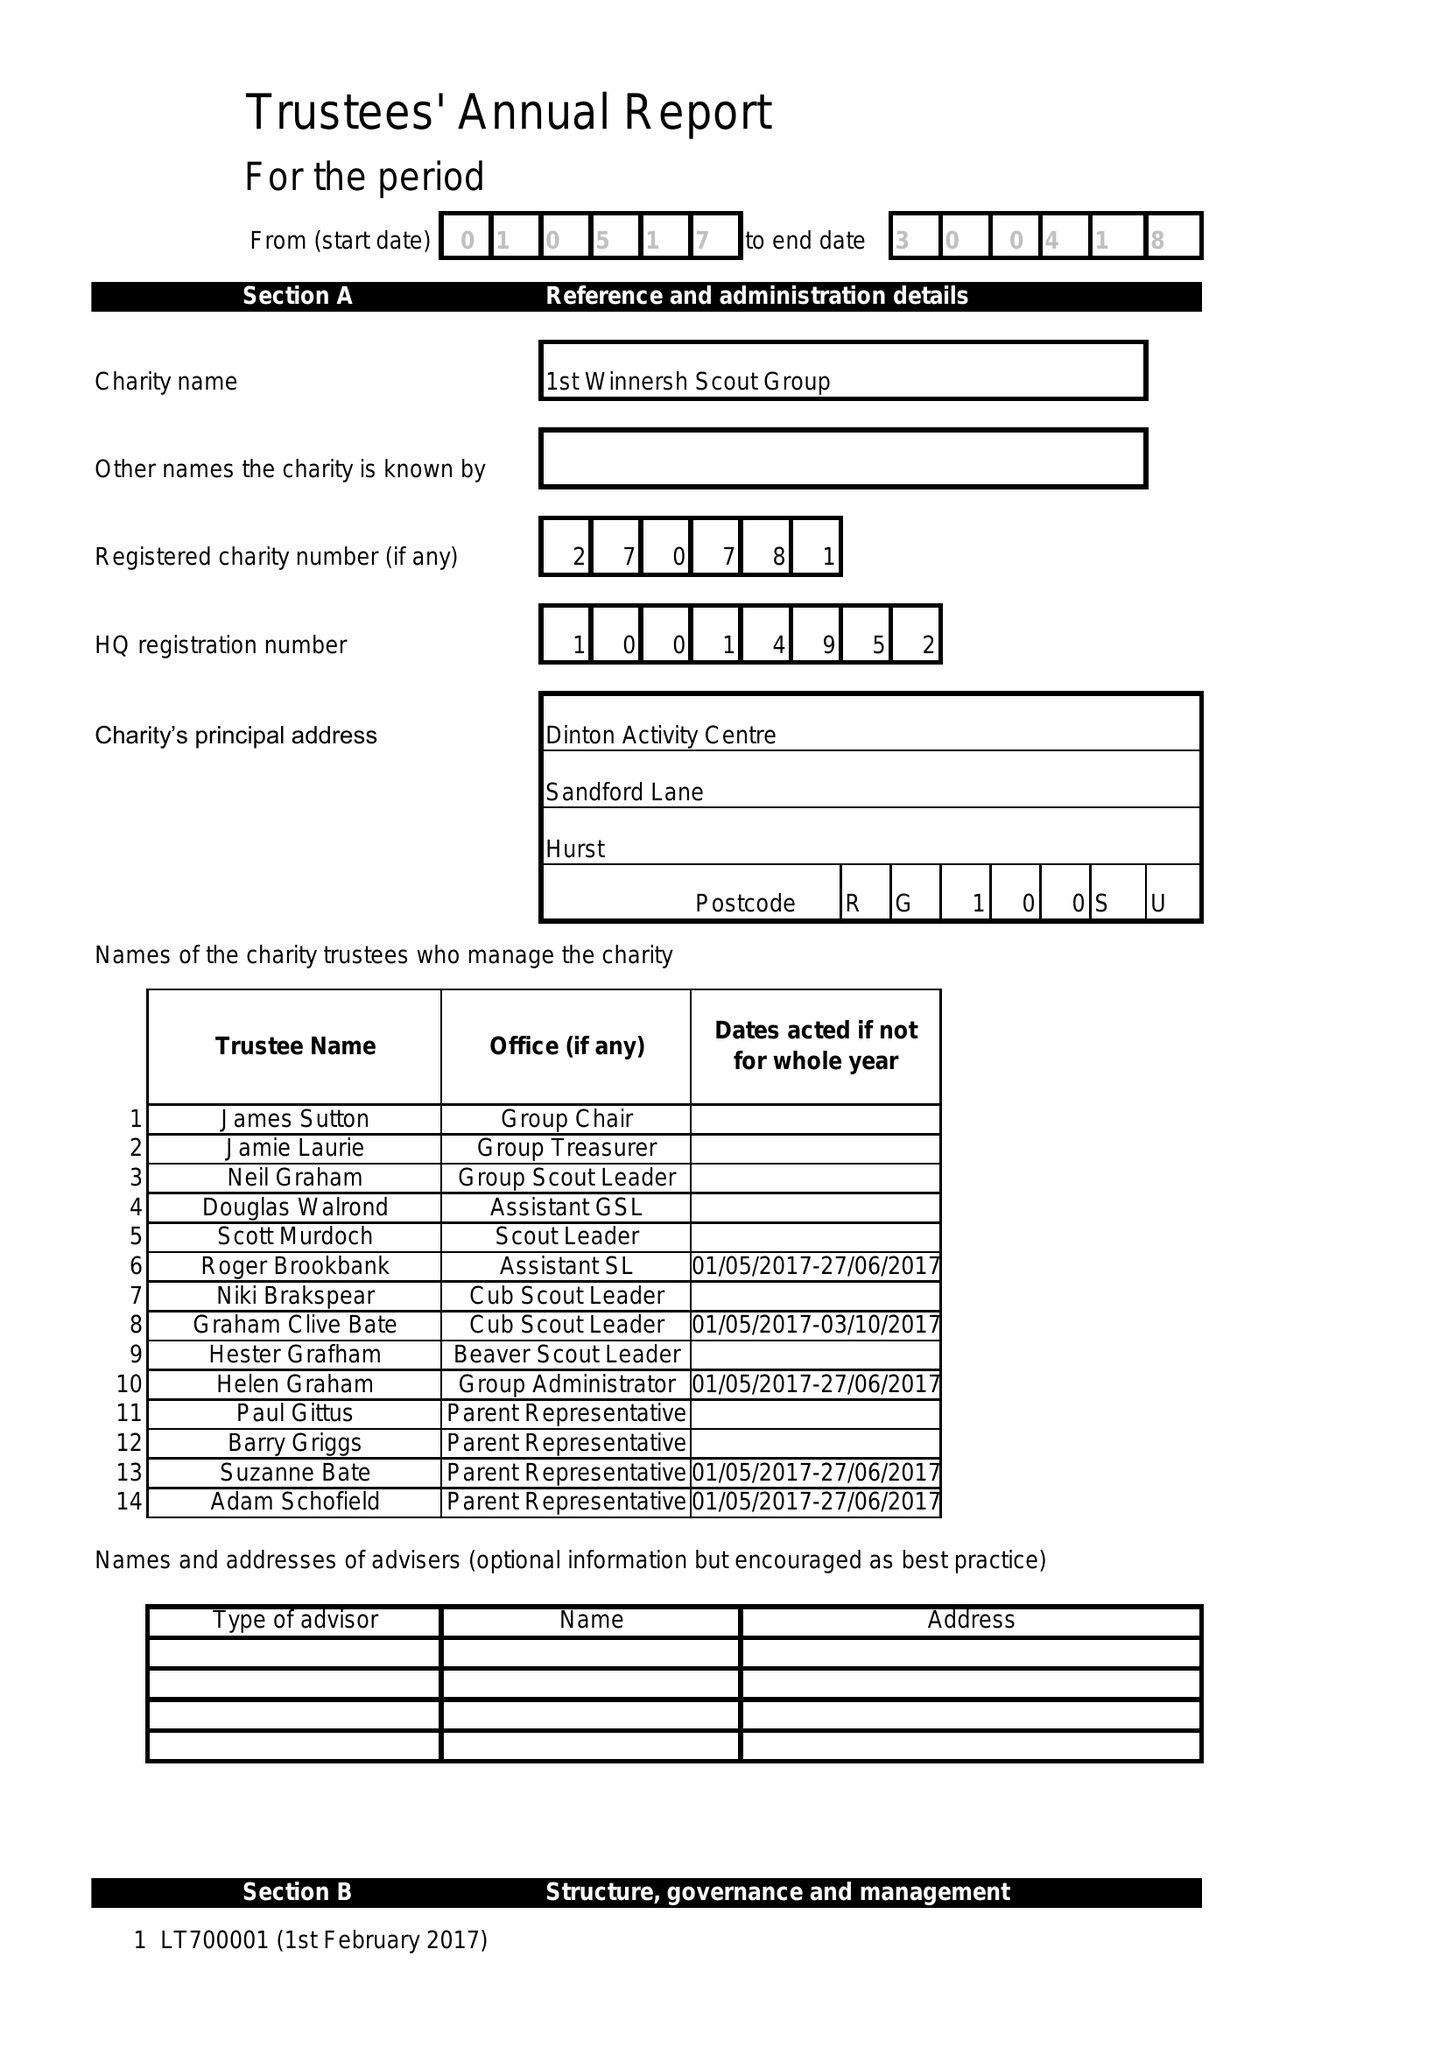What is the value for the address__street_line?
Answer the question using a single word or phrase. None 